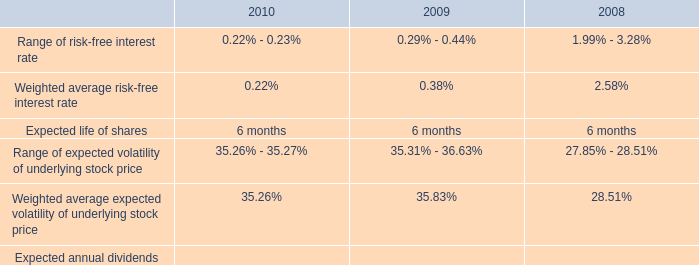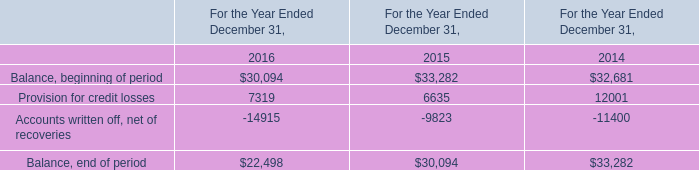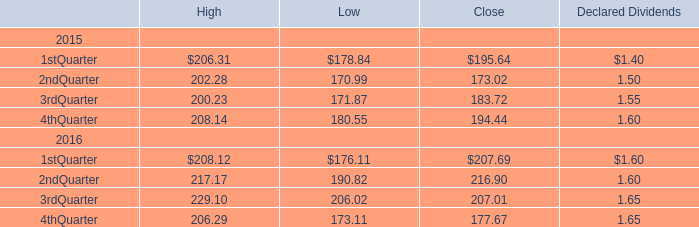what was the percentage change in the weighted average fair value for the espp shares purchased from 2009 to 2010 
Computations: ((9.43 - 6.65) / 6.65)
Answer: 0.41805. 